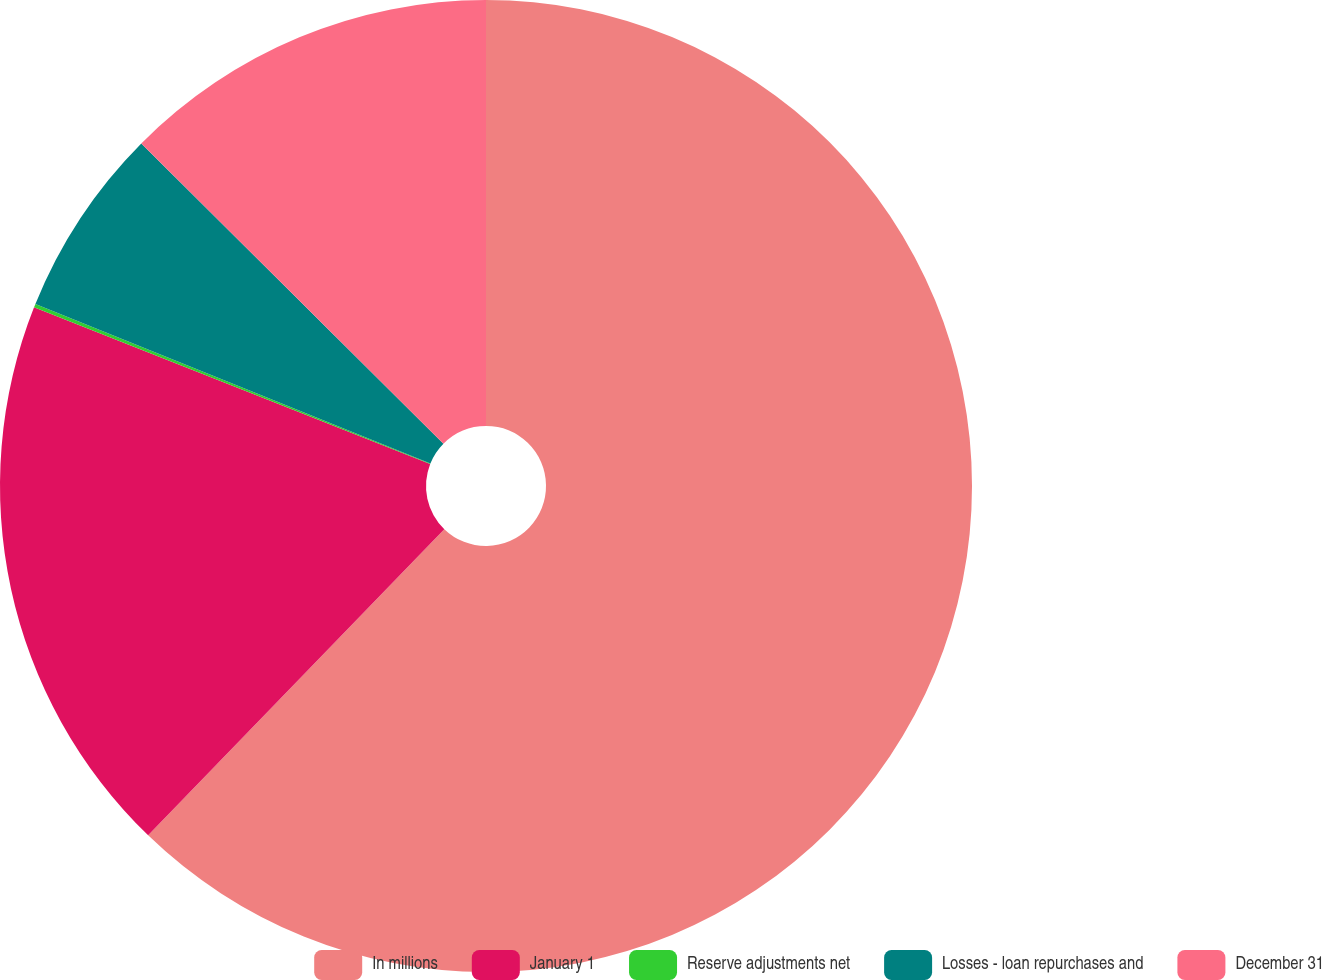<chart> <loc_0><loc_0><loc_500><loc_500><pie_chart><fcel>In millions<fcel>January 1<fcel>Reserve adjustments net<fcel>Losses - loan repurchases and<fcel>December 31<nl><fcel>62.24%<fcel>18.76%<fcel>0.12%<fcel>6.34%<fcel>12.55%<nl></chart> 